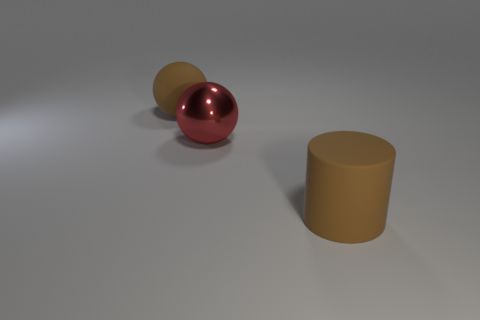There is another object that is the same shape as the big metallic object; what color is it?
Ensure brevity in your answer.  Brown. Is the red shiny sphere the same size as the brown cylinder?
Provide a short and direct response. Yes. There is a big brown thing that is on the left side of the big cylinder; what is it made of?
Give a very brief answer. Rubber. What number of other things are there of the same shape as the metallic object?
Provide a short and direct response. 1. Are there any big metal balls on the right side of the matte cylinder?
Your answer should be very brief. No. What number of objects are purple shiny cubes or large balls?
Offer a very short reply. 2. What number of brown rubber objects are behind the metallic ball and in front of the shiny object?
Keep it short and to the point. 0. There is a matte object that is on the right side of the large red object; is it the same size as the sphere to the right of the large brown rubber sphere?
Make the answer very short. Yes. There is a brown rubber object that is left of the large cylinder; how big is it?
Offer a very short reply. Large. What number of objects are either things that are left of the rubber cylinder or things that are in front of the red thing?
Your response must be concise. 3. 